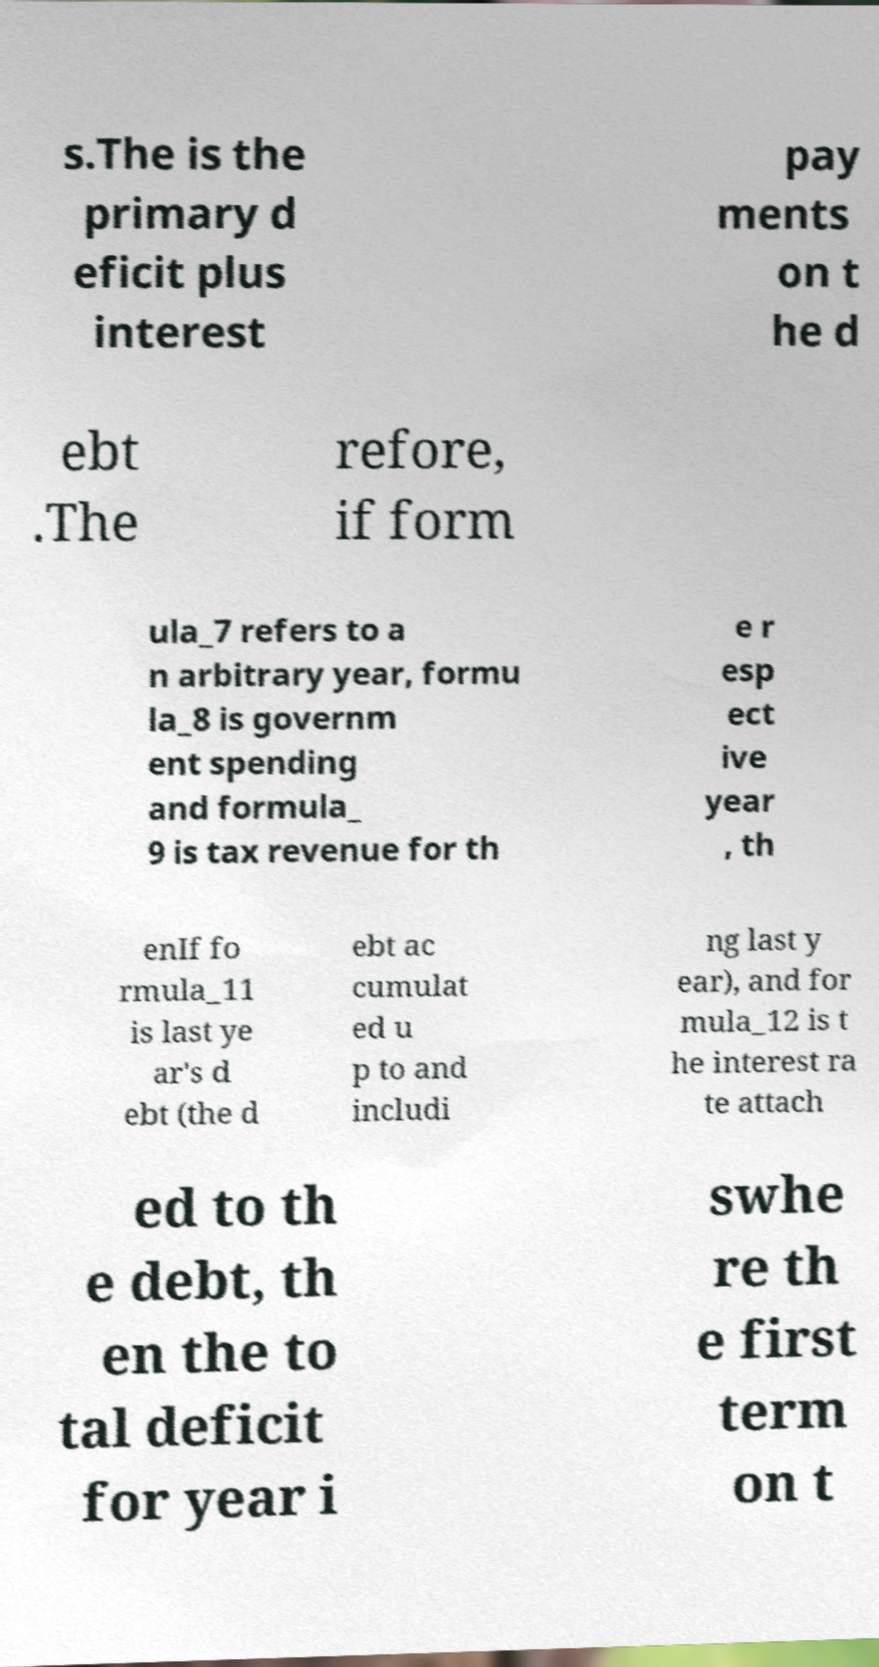Could you assist in decoding the text presented in this image and type it out clearly? s.The is the primary d eficit plus interest pay ments on t he d ebt .The refore, if form ula_7 refers to a n arbitrary year, formu la_8 is governm ent spending and formula_ 9 is tax revenue for th e r esp ect ive year , th enIf fo rmula_11 is last ye ar's d ebt (the d ebt ac cumulat ed u p to and includi ng last y ear), and for mula_12 is t he interest ra te attach ed to th e debt, th en the to tal deficit for year i swhe re th e first term on t 